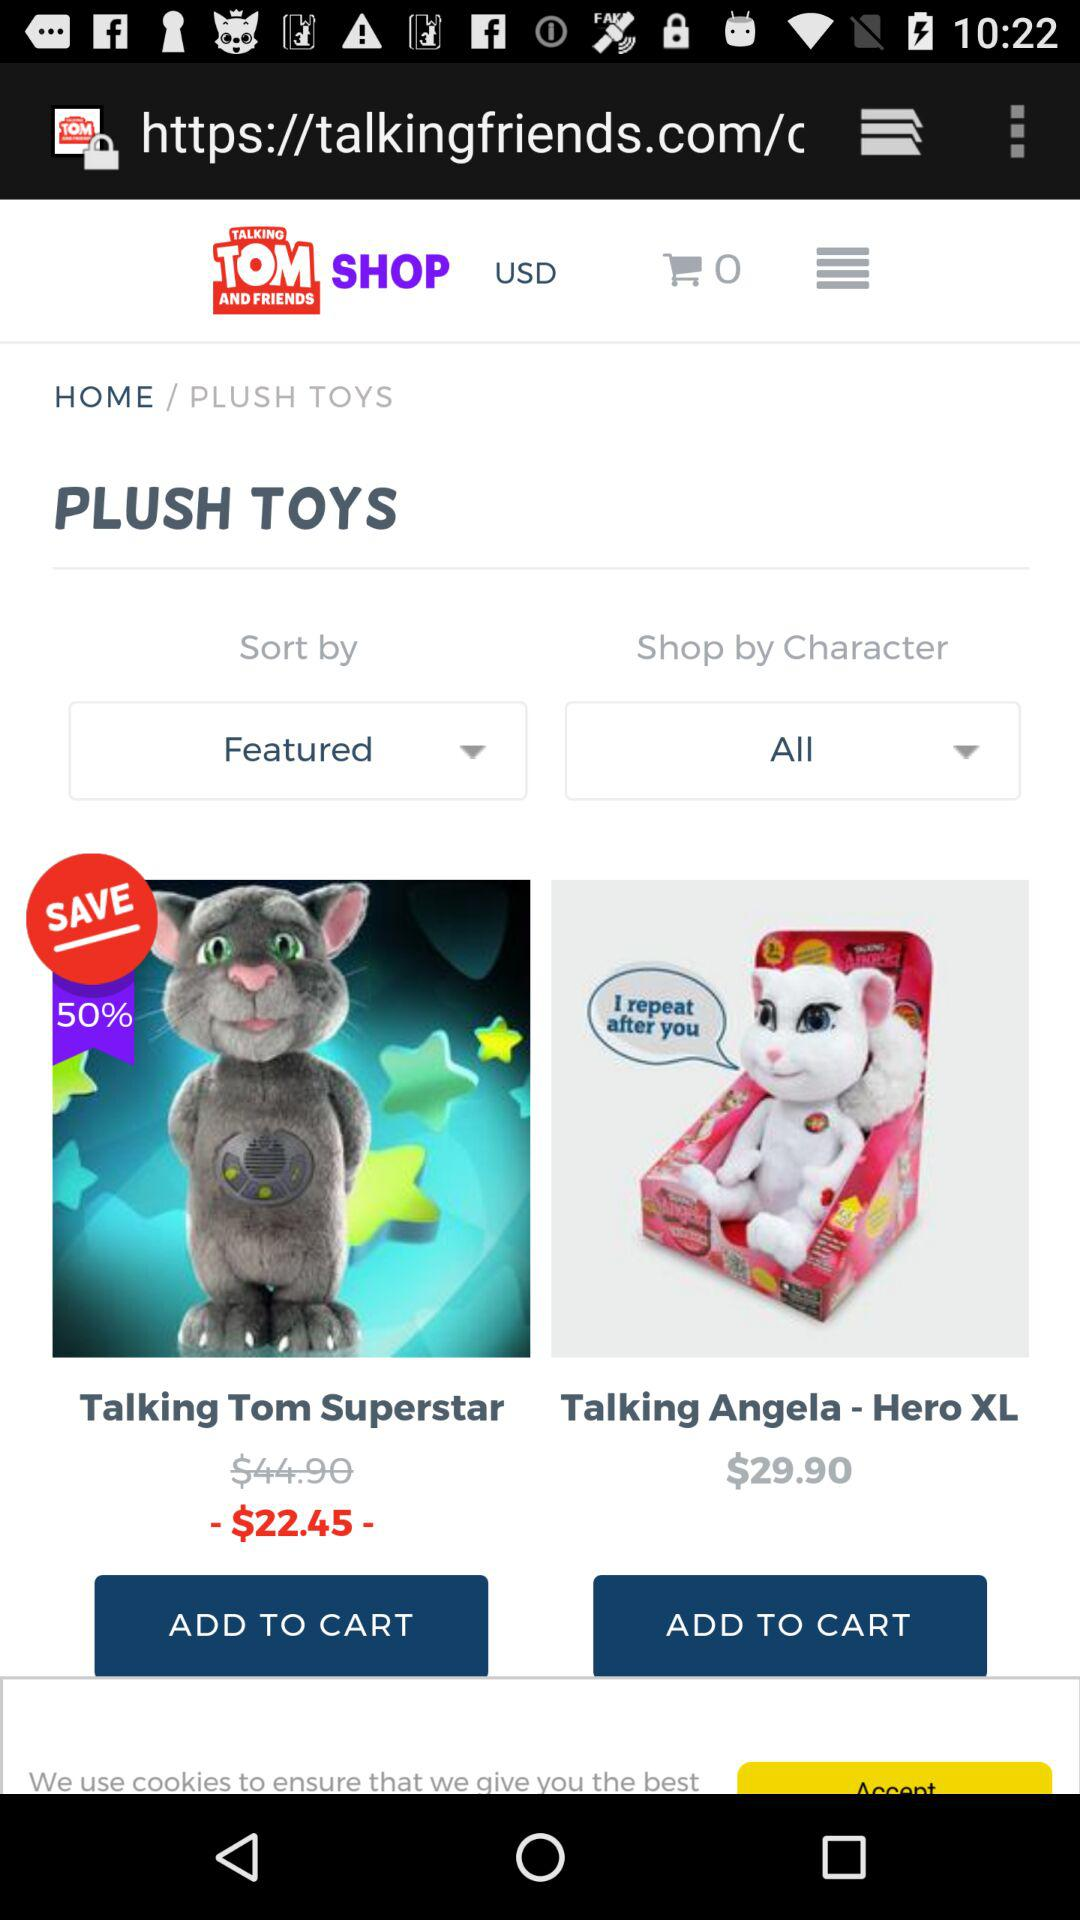What is the original price of "Talking Angela - Hero XL"? The original price of "Talking Angela - Hero XL" is $29.90. 